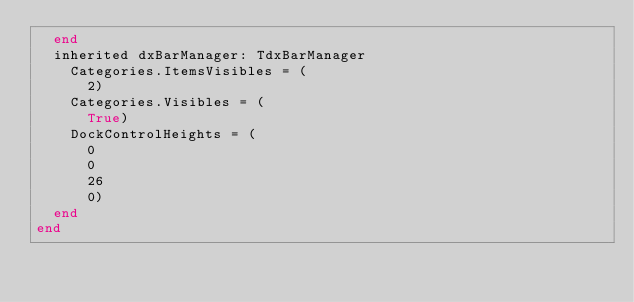<code> <loc_0><loc_0><loc_500><loc_500><_Pascal_>  end
  inherited dxBarManager: TdxBarManager
    Categories.ItemsVisibles = (
      2)
    Categories.Visibles = (
      True)
    DockControlHeights = (
      0
      0
      26
      0)
  end
end
</code> 